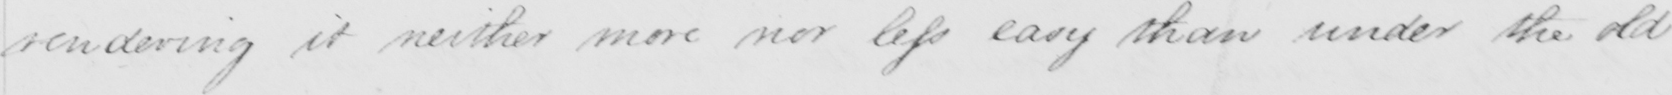What is written in this line of handwriting? rendering it neither more nor less easy than under the old 